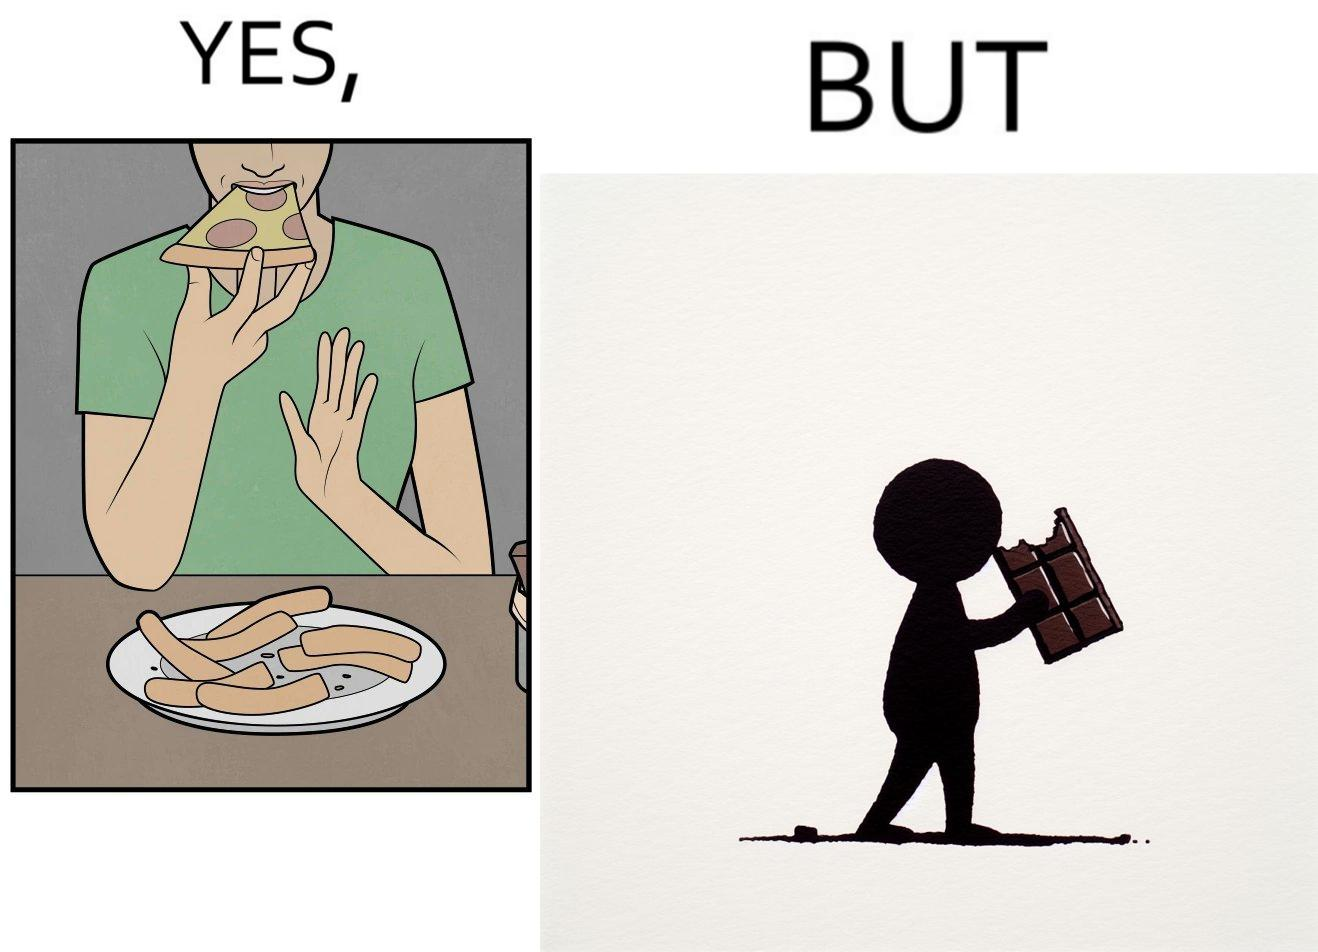Explain the humor or irony in this image. the irony in this image is that people waste pizza crust by saying that it is too hard, while they eat hard chocolate without any complaints 